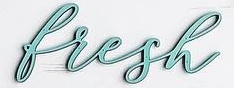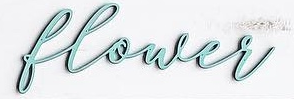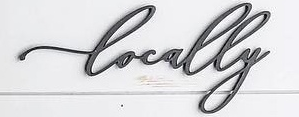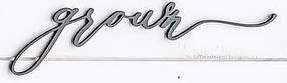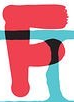Transcribe the words shown in these images in order, separated by a semicolon. bresh; blower; Locally; grown; F 